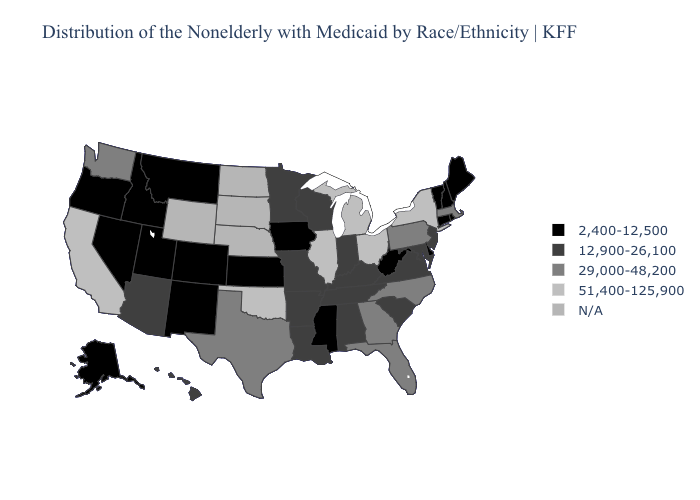What is the value of New Mexico?
Short answer required. 2,400-12,500. What is the value of Texas?
Write a very short answer. 29,000-48,200. What is the lowest value in states that border Indiana?
Be succinct. 12,900-26,100. Does Arizona have the highest value in the USA?
Concise answer only. No. Which states have the highest value in the USA?
Short answer required. California, Illinois, Michigan, New York, Ohio, Oklahoma. Name the states that have a value in the range 2,400-12,500?
Short answer required. Alaska, Colorado, Connecticut, Delaware, Idaho, Iowa, Kansas, Maine, Mississippi, Montana, Nevada, New Hampshire, New Mexico, Oregon, Rhode Island, Utah, Vermont, West Virginia. Does Delaware have the highest value in the USA?
Write a very short answer. No. Name the states that have a value in the range 2,400-12,500?
Give a very brief answer. Alaska, Colorado, Connecticut, Delaware, Idaho, Iowa, Kansas, Maine, Mississippi, Montana, Nevada, New Hampshire, New Mexico, Oregon, Rhode Island, Utah, Vermont, West Virginia. What is the value of North Dakota?
Quick response, please. N/A. Does New Mexico have the highest value in the USA?
Keep it brief. No. What is the value of Alaska?
Keep it brief. 2,400-12,500. What is the value of Alaska?
Write a very short answer. 2,400-12,500. Does Missouri have the lowest value in the MidWest?
Be succinct. No. What is the value of Kansas?
Answer briefly. 2,400-12,500. 